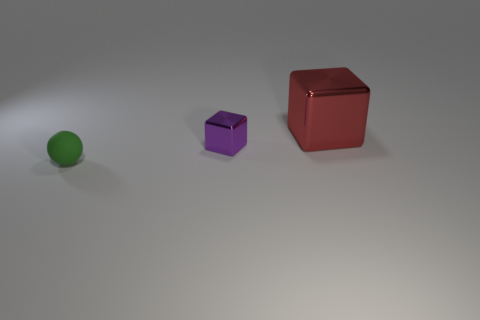Can you describe the position of the red cube relative to the green sphere? The red cube is positioned diagonally to the right and slightly behind the green sphere from the perspective of the camera angle. There's a notable distance separating the two objects. 